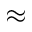Convert formula to latex. <formula><loc_0><loc_0><loc_500><loc_500>\approx</formula> 